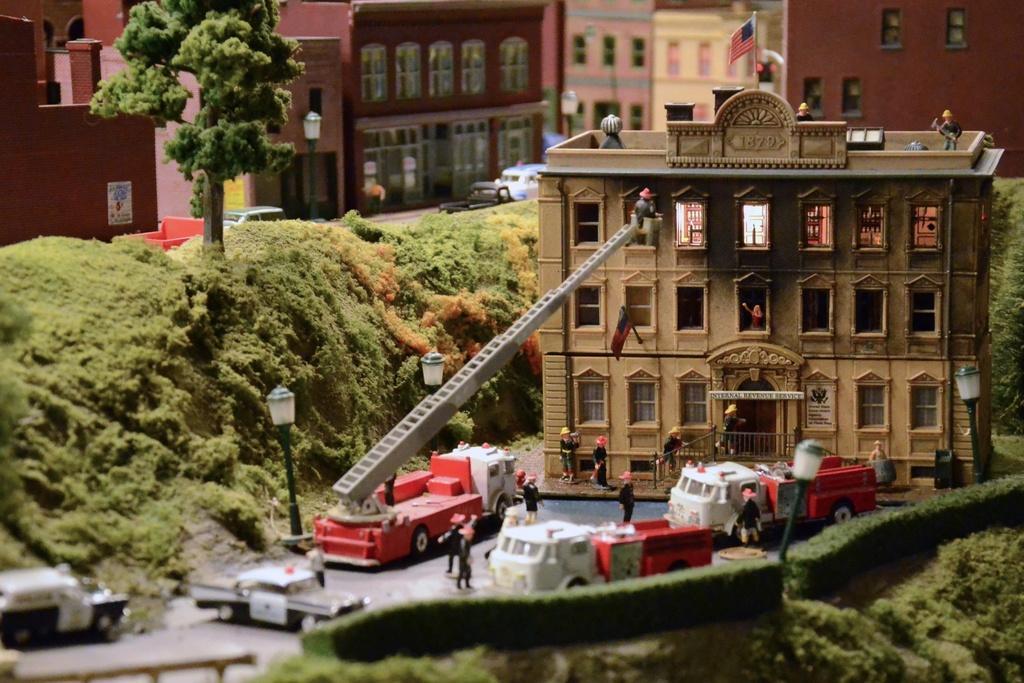Can you describe this image briefly? It is a project and there are pictures of a building and there are some vehicles in front of the building and the workers are working on the building,there are a lot of trees and grass around the building,there are many other towers around the building. 